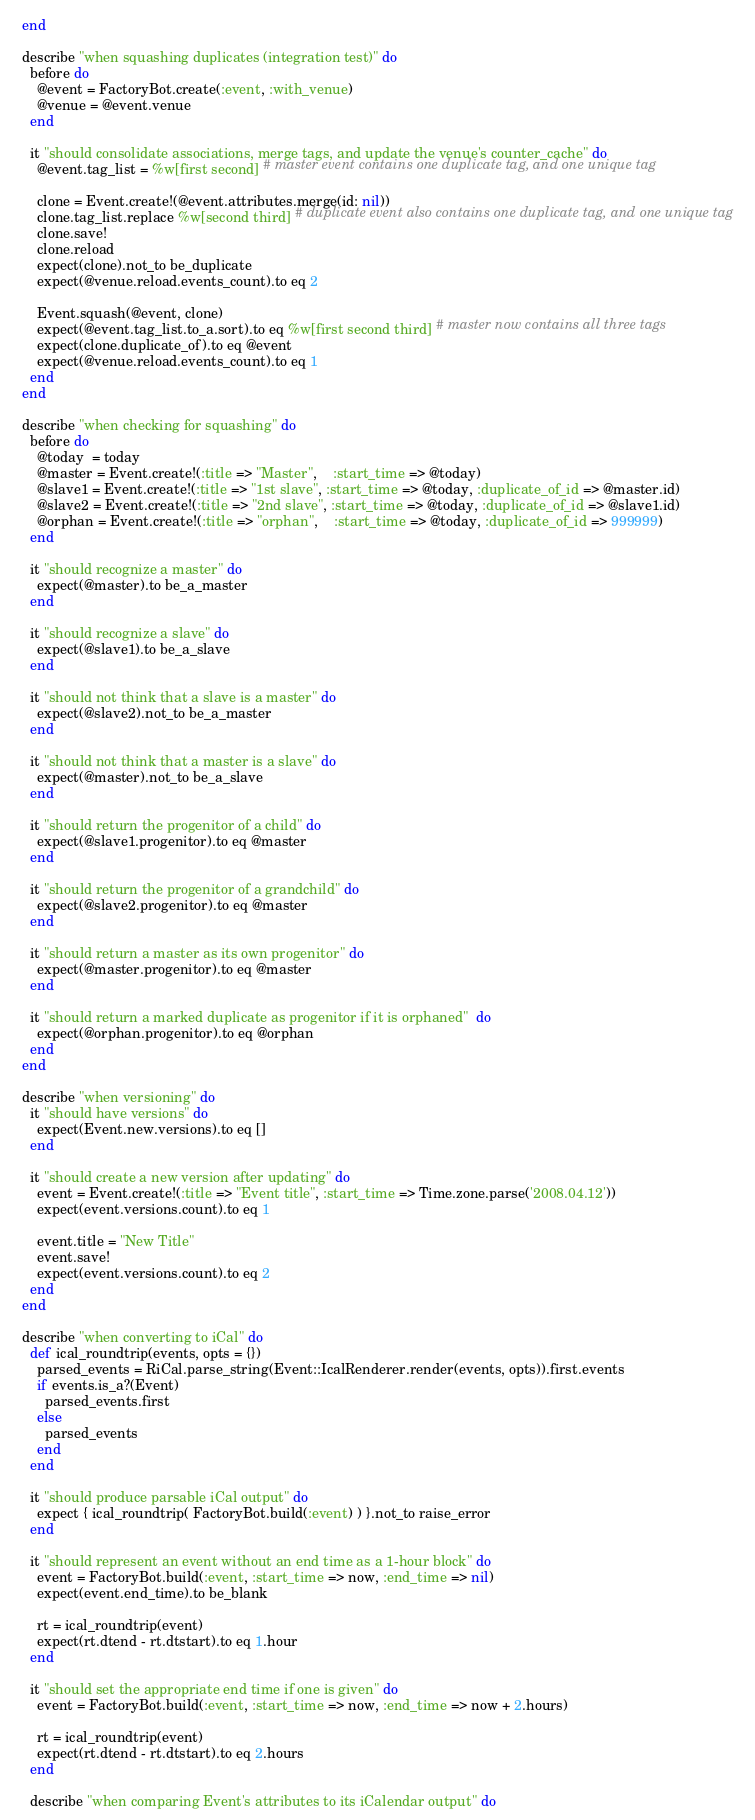<code> <loc_0><loc_0><loc_500><loc_500><_Ruby_>  end

  describe "when squashing duplicates (integration test)" do
    before do
      @event = FactoryBot.create(:event, :with_venue)
      @venue = @event.venue
    end

    it "should consolidate associations, merge tags, and update the venue's counter_cache" do
      @event.tag_list = %w[first second] # master event contains one duplicate tag, and one unique tag

      clone = Event.create!(@event.attributes.merge(id: nil))
      clone.tag_list.replace %w[second third] # duplicate event also contains one duplicate tag, and one unique tag
      clone.save!
      clone.reload
      expect(clone).not_to be_duplicate
      expect(@venue.reload.events_count).to eq 2

      Event.squash(@event, clone)
      expect(@event.tag_list.to_a.sort).to eq %w[first second third] # master now contains all three tags
      expect(clone.duplicate_of).to eq @event
      expect(@venue.reload.events_count).to eq 1
    end
  end

  describe "when checking for squashing" do
    before do
      @today  = today
      @master = Event.create!(:title => "Master",    :start_time => @today)
      @slave1 = Event.create!(:title => "1st slave", :start_time => @today, :duplicate_of_id => @master.id)
      @slave2 = Event.create!(:title => "2nd slave", :start_time => @today, :duplicate_of_id => @slave1.id)
      @orphan = Event.create!(:title => "orphan",    :start_time => @today, :duplicate_of_id => 999999)
    end

    it "should recognize a master" do
      expect(@master).to be_a_master
    end

    it "should recognize a slave" do
      expect(@slave1).to be_a_slave
    end

    it "should not think that a slave is a master" do
      expect(@slave2).not_to be_a_master
    end

    it "should not think that a master is a slave" do
      expect(@master).not_to be_a_slave
    end

    it "should return the progenitor of a child" do
      expect(@slave1.progenitor).to eq @master
    end

    it "should return the progenitor of a grandchild" do
      expect(@slave2.progenitor).to eq @master
    end

    it "should return a master as its own progenitor" do
      expect(@master.progenitor).to eq @master
    end

    it "should return a marked duplicate as progenitor if it is orphaned"  do
      expect(@orphan.progenitor).to eq @orphan
    end
  end

  describe "when versioning" do
    it "should have versions" do
      expect(Event.new.versions).to eq []
    end

    it "should create a new version after updating" do
      event = Event.create!(:title => "Event title", :start_time => Time.zone.parse('2008.04.12'))
      expect(event.versions.count).to eq 1

      event.title = "New Title"
      event.save!
      expect(event.versions.count).to eq 2
    end
  end

  describe "when converting to iCal" do
    def ical_roundtrip(events, opts = {})
      parsed_events = RiCal.parse_string(Event::IcalRenderer.render(events, opts)).first.events
      if events.is_a?(Event)
        parsed_events.first
      else
        parsed_events
      end
    end

    it "should produce parsable iCal output" do
      expect { ical_roundtrip( FactoryBot.build(:event) ) }.not_to raise_error
    end

    it "should represent an event without an end time as a 1-hour block" do
      event = FactoryBot.build(:event, :start_time => now, :end_time => nil)
      expect(event.end_time).to be_blank

      rt = ical_roundtrip(event)
      expect(rt.dtend - rt.dtstart).to eq 1.hour
    end

    it "should set the appropriate end time if one is given" do
      event = FactoryBot.build(:event, :start_time => now, :end_time => now + 2.hours)

      rt = ical_roundtrip(event)
      expect(rt.dtend - rt.dtstart).to eq 2.hours
    end

    describe "when comparing Event's attributes to its iCalendar output" do</code> 